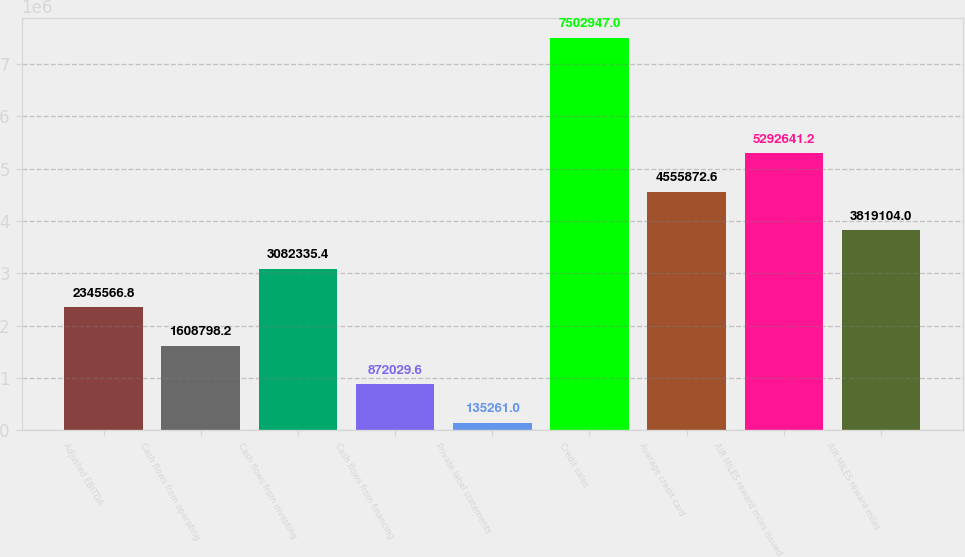Convert chart. <chart><loc_0><loc_0><loc_500><loc_500><bar_chart><fcel>Adjusted EBITDA<fcel>Cash flows from operating<fcel>Cash flows from investing<fcel>Cash flows from financing<fcel>Private label statements<fcel>Credit sales<fcel>Average credit card<fcel>AIR MILES reward miles issued<fcel>AIR MILES reward miles<nl><fcel>2.34557e+06<fcel>1.6088e+06<fcel>3.08234e+06<fcel>872030<fcel>135261<fcel>7.50295e+06<fcel>4.55587e+06<fcel>5.29264e+06<fcel>3.8191e+06<nl></chart> 